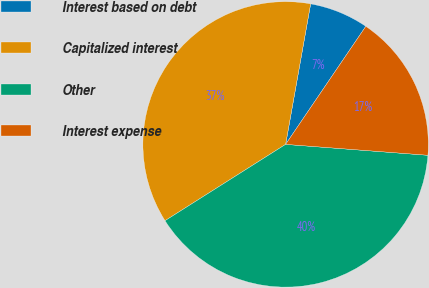Convert chart to OTSL. <chart><loc_0><loc_0><loc_500><loc_500><pie_chart><fcel>Interest based on debt<fcel>Capitalized interest<fcel>Other<fcel>Interest expense<nl><fcel>6.69%<fcel>36.79%<fcel>39.8%<fcel>16.72%<nl></chart> 